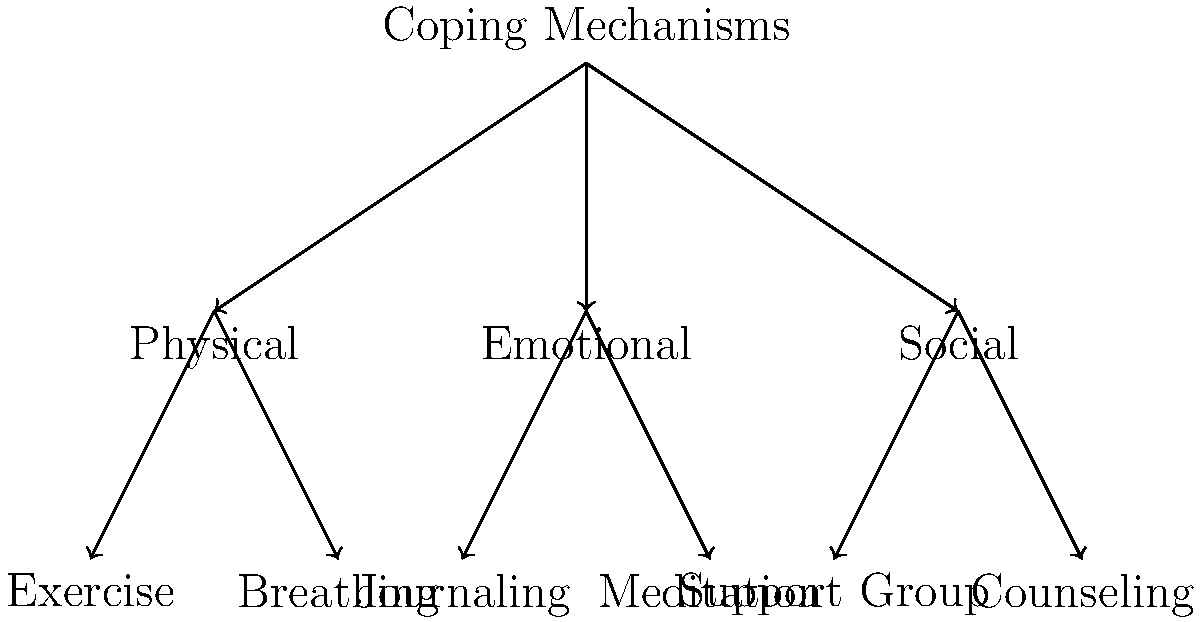Analyze the branching tree structure representing coping mechanisms. How many primary categories of coping mechanisms are shown, and what is the total number of specific coping strategies illustrated? To answer this question, we need to examine the structure of the tree diagram:

1. First, identify the primary categories:
   - The tree branches out from the root "Coping Mechanisms" into three main branches.
   - These three branches represent the primary categories: Physical, Emotional, and Social.

2. Count the primary categories:
   - There are 3 primary categories of coping mechanisms shown.

3. Next, identify and count the specific coping strategies:
   - Under "Physical": Exercise and Breathing (2 strategies)
   - Under "Emotional": Journaling and Meditation (2 strategies)
   - Under "Social": Support Group and Counseling (2 strategies)

4. Calculate the total number of specific coping strategies:
   - 2 + 2 + 2 = 6 specific coping strategies in total

Therefore, the tree structure shows 3 primary categories of coping mechanisms and 6 specific coping strategies.
Answer: 3 primary categories, 6 specific strategies 